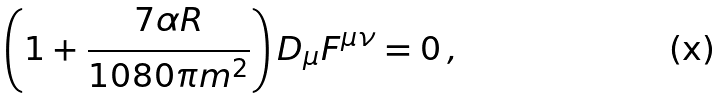<formula> <loc_0><loc_0><loc_500><loc_500>\left ( 1 + \frac { 7 \alpha R } { 1 0 8 0 \pi m ^ { 2 } } \right ) D _ { \mu } F ^ { \mu \nu } = 0 \, ,</formula> 